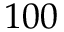<formula> <loc_0><loc_0><loc_500><loc_500>1 0 0</formula> 